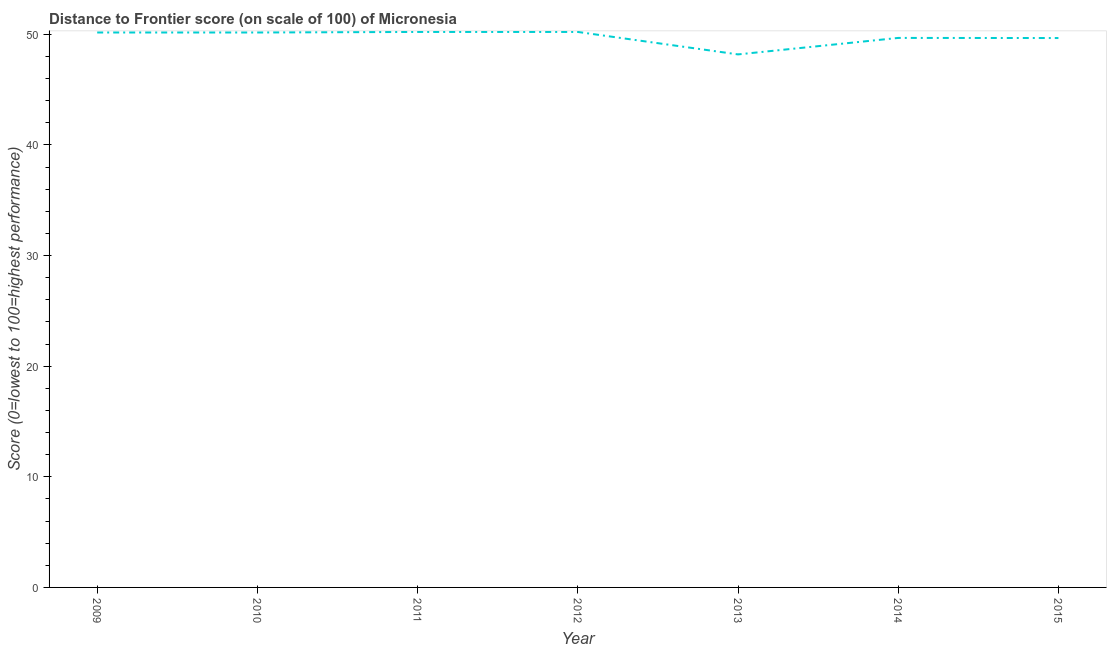What is the distance to frontier score in 2013?
Make the answer very short. 48.19. Across all years, what is the maximum distance to frontier score?
Your answer should be compact. 50.22. Across all years, what is the minimum distance to frontier score?
Your answer should be compact. 48.19. In which year was the distance to frontier score maximum?
Keep it short and to the point. 2011. In which year was the distance to frontier score minimum?
Offer a terse response. 2013. What is the sum of the distance to frontier score?
Provide a succinct answer. 348.32. What is the difference between the distance to frontier score in 2013 and 2015?
Your response must be concise. -1.48. What is the average distance to frontier score per year?
Your answer should be compact. 49.76. What is the median distance to frontier score?
Provide a succinct answer. 50.17. What is the ratio of the distance to frontier score in 2010 to that in 2011?
Provide a succinct answer. 1. Is the difference between the distance to frontier score in 2012 and 2014 greater than the difference between any two years?
Provide a succinct answer. No. Is the sum of the distance to frontier score in 2010 and 2013 greater than the maximum distance to frontier score across all years?
Give a very brief answer. Yes. What is the difference between the highest and the lowest distance to frontier score?
Your answer should be compact. 2.03. In how many years, is the distance to frontier score greater than the average distance to frontier score taken over all years?
Provide a succinct answer. 4. What is the difference between two consecutive major ticks on the Y-axis?
Keep it short and to the point. 10. What is the title of the graph?
Offer a very short reply. Distance to Frontier score (on scale of 100) of Micronesia. What is the label or title of the X-axis?
Offer a terse response. Year. What is the label or title of the Y-axis?
Your answer should be very brief. Score (0=lowest to 100=highest performance). What is the Score (0=lowest to 100=highest performance) in 2009?
Your response must be concise. 50.17. What is the Score (0=lowest to 100=highest performance) of 2010?
Your answer should be compact. 50.17. What is the Score (0=lowest to 100=highest performance) in 2011?
Provide a succinct answer. 50.22. What is the Score (0=lowest to 100=highest performance) in 2012?
Provide a succinct answer. 50.22. What is the Score (0=lowest to 100=highest performance) of 2013?
Your response must be concise. 48.19. What is the Score (0=lowest to 100=highest performance) of 2014?
Your response must be concise. 49.68. What is the Score (0=lowest to 100=highest performance) of 2015?
Give a very brief answer. 49.67. What is the difference between the Score (0=lowest to 100=highest performance) in 2009 and 2010?
Offer a terse response. 0. What is the difference between the Score (0=lowest to 100=highest performance) in 2009 and 2011?
Keep it short and to the point. -0.05. What is the difference between the Score (0=lowest to 100=highest performance) in 2009 and 2012?
Provide a short and direct response. -0.05. What is the difference between the Score (0=lowest to 100=highest performance) in 2009 and 2013?
Provide a short and direct response. 1.98. What is the difference between the Score (0=lowest to 100=highest performance) in 2009 and 2014?
Ensure brevity in your answer.  0.49. What is the difference between the Score (0=lowest to 100=highest performance) in 2009 and 2015?
Provide a short and direct response. 0.5. What is the difference between the Score (0=lowest to 100=highest performance) in 2010 and 2011?
Provide a succinct answer. -0.05. What is the difference between the Score (0=lowest to 100=highest performance) in 2010 and 2012?
Offer a very short reply. -0.05. What is the difference between the Score (0=lowest to 100=highest performance) in 2010 and 2013?
Give a very brief answer. 1.98. What is the difference between the Score (0=lowest to 100=highest performance) in 2010 and 2014?
Your response must be concise. 0.49. What is the difference between the Score (0=lowest to 100=highest performance) in 2010 and 2015?
Offer a very short reply. 0.5. What is the difference between the Score (0=lowest to 100=highest performance) in 2011 and 2013?
Your response must be concise. 2.03. What is the difference between the Score (0=lowest to 100=highest performance) in 2011 and 2014?
Provide a short and direct response. 0.54. What is the difference between the Score (0=lowest to 100=highest performance) in 2011 and 2015?
Provide a short and direct response. 0.55. What is the difference between the Score (0=lowest to 100=highest performance) in 2012 and 2013?
Your response must be concise. 2.03. What is the difference between the Score (0=lowest to 100=highest performance) in 2012 and 2014?
Offer a terse response. 0.54. What is the difference between the Score (0=lowest to 100=highest performance) in 2012 and 2015?
Your answer should be compact. 0.55. What is the difference between the Score (0=lowest to 100=highest performance) in 2013 and 2014?
Offer a very short reply. -1.49. What is the difference between the Score (0=lowest to 100=highest performance) in 2013 and 2015?
Your response must be concise. -1.48. What is the difference between the Score (0=lowest to 100=highest performance) in 2014 and 2015?
Your response must be concise. 0.01. What is the ratio of the Score (0=lowest to 100=highest performance) in 2009 to that in 2012?
Ensure brevity in your answer.  1. What is the ratio of the Score (0=lowest to 100=highest performance) in 2009 to that in 2013?
Your answer should be very brief. 1.04. What is the ratio of the Score (0=lowest to 100=highest performance) in 2009 to that in 2015?
Make the answer very short. 1.01. What is the ratio of the Score (0=lowest to 100=highest performance) in 2010 to that in 2013?
Provide a short and direct response. 1.04. What is the ratio of the Score (0=lowest to 100=highest performance) in 2010 to that in 2015?
Ensure brevity in your answer.  1.01. What is the ratio of the Score (0=lowest to 100=highest performance) in 2011 to that in 2013?
Offer a very short reply. 1.04. What is the ratio of the Score (0=lowest to 100=highest performance) in 2011 to that in 2015?
Give a very brief answer. 1.01. What is the ratio of the Score (0=lowest to 100=highest performance) in 2012 to that in 2013?
Your response must be concise. 1.04. What is the ratio of the Score (0=lowest to 100=highest performance) in 2012 to that in 2015?
Provide a succinct answer. 1.01. What is the ratio of the Score (0=lowest to 100=highest performance) in 2013 to that in 2014?
Make the answer very short. 0.97. What is the ratio of the Score (0=lowest to 100=highest performance) in 2013 to that in 2015?
Provide a succinct answer. 0.97. What is the ratio of the Score (0=lowest to 100=highest performance) in 2014 to that in 2015?
Provide a short and direct response. 1. 